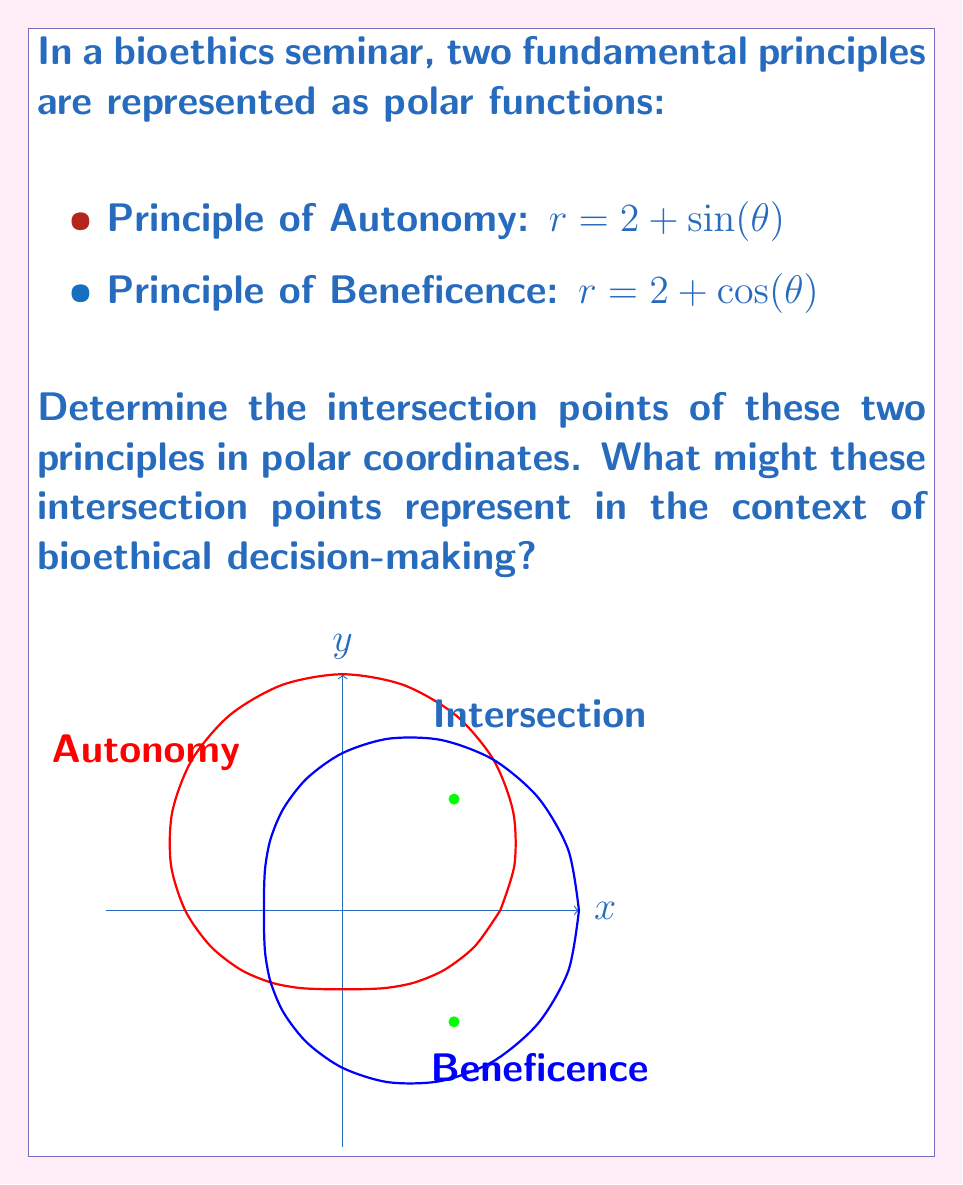Help me with this question. To find the intersection points, we need to equate the two functions:

$$2 + \sin(\theta) = 2 + \cos(\theta)$$

Simplifying:

$$\sin(\theta) = \cos(\theta)$$

This equation is satisfied when $\theta = \frac{\pi}{4}$ or $\theta = \frac{5\pi}{4}$ in the interval $[0, 2\pi]$.

For $\theta = \frac{\pi}{4}$:
$$r = 2 + \sin(\frac{\pi}{4}) = 2 + \frac{\sqrt{2}}{2} = 2 + \frac{1}{\sqrt{2}} = \frac{2\sqrt{2} + 1}{\sqrt{2}}$$

For $\theta = \frac{5\pi}{4}$:
$$r = 2 + \sin(\frac{5\pi}{4}) = 2 - \frac{\sqrt{2}}{2} = 2 - \frac{1}{\sqrt{2}} = \frac{2\sqrt{2} - 1}{\sqrt{2}}$$

Converting to Cartesian coordinates:

For $\theta = \frac{\pi}{4}$:
$$x = r\cos(\theta) = (\frac{2\sqrt{2} + 1}{\sqrt{2}})(\frac{\sqrt{2}}{2}) = \sqrt{2}$$
$$y = r\sin(\theta) = (\frac{2\sqrt{2} + 1}{\sqrt{2}})(\frac{\sqrt{2}}{2}) = \sqrt{2}$$

For $\theta = \frac{5\pi}{4}$:
$$x = r\cos(\theta) = (\frac{2\sqrt{2} - 1}{\sqrt{2}})(-\frac{\sqrt{2}}{2}) = -\sqrt{2}$$
$$y = r\sin(\theta) = (\frac{2\sqrt{2} - 1}{\sqrt{2}})(-\frac{\sqrt{2}}{2}) = -\sqrt{2}$$

In the context of bioethical decision-making, these intersection points could represent situations where the principles of autonomy and beneficence are equally weighted or balanced. They might indicate scenarios where respecting a patient's autonomy aligns perfectly with acting in their best interest.
Answer: $(\sqrt{2}, \sqrt{2})$ and $(-\sqrt{2}, -\sqrt{2})$ in Cartesian coordinates; $(\frac{2\sqrt{2} + 1}{\sqrt{2}}, \frac{\pi}{4})$ and $(\frac{2\sqrt{2} - 1}{\sqrt{2}}, \frac{5\pi}{4})$ in polar coordinates. 